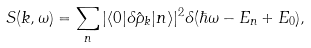Convert formula to latex. <formula><loc_0><loc_0><loc_500><loc_500>S ( k , \omega ) = \sum _ { n } | \langle 0 | \delta \hat { \rho } _ { k } | n \rangle | ^ { 2 } \delta ( \hbar { \omega } - E _ { n } + E _ { 0 } ) ,</formula> 